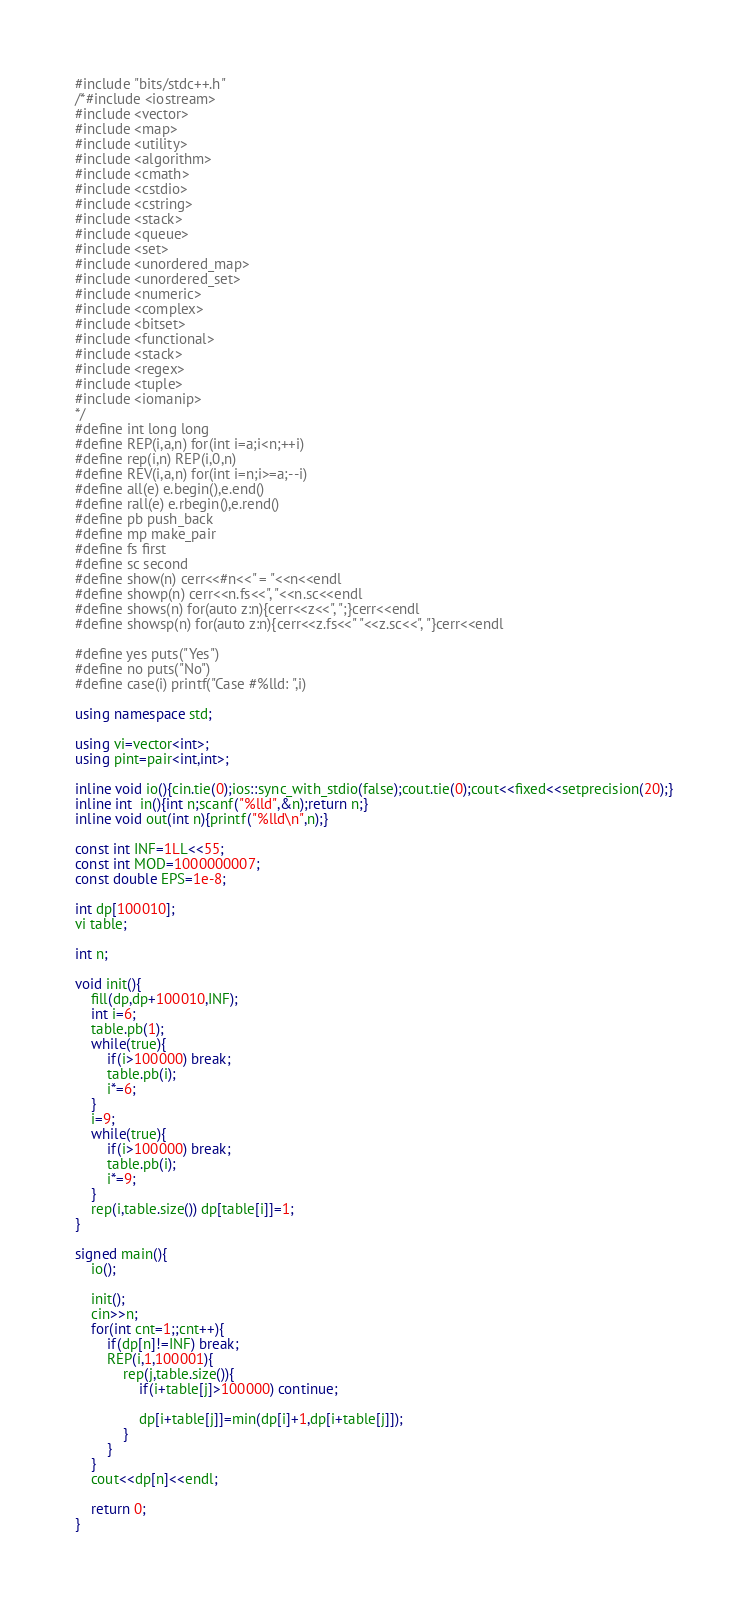<code> <loc_0><loc_0><loc_500><loc_500><_C++_>#include "bits/stdc++.h"
/*#include <iostream>
#include <vector>
#include <map>
#include <utility>
#include <algorithm>
#include <cmath>
#include <cstdio>
#include <cstring>
#include <stack>
#include <queue>
#include <set>
#include <unordered_map>
#include <unordered_set>
#include <numeric>
#include <complex>
#include <bitset>
#include <functional>
#include <stack>
#include <regex>
#include <tuple>
#include <iomanip>
*/
#define int long long
#define REP(i,a,n) for(int i=a;i<n;++i)
#define rep(i,n) REP(i,0,n)
#define REV(i,a,n) for(int i=n;i>=a;--i)
#define all(e) e.begin(),e.end()
#define rall(e) e.rbegin(),e.rend()
#define pb push_back
#define mp make_pair
#define fs first
#define sc second
#define show(n) cerr<<#n<<" = "<<n<<endl
#define showp(n) cerr<<n.fs<<", "<<n.sc<<endl
#define shows(n) for(auto z:n){cerr<<z<<", ";}cerr<<endl
#define showsp(n) for(auto z:n){cerr<<z.fs<<" "<<z.sc<<", "}cerr<<endl

#define yes puts("Yes")
#define no puts("No")
#define case(i) printf("Case #%lld: ",i)

using namespace std;

using vi=vector<int>;
using pint=pair<int,int>;

inline void io(){cin.tie(0);ios::sync_with_stdio(false);cout.tie(0);cout<<fixed<<setprecision(20);}
inline int  in(){int n;scanf("%lld",&n);return n;}
inline void out(int n){printf("%lld\n",n);}

const int INF=1LL<<55;
const int MOD=1000000007;
const double EPS=1e-8;

int dp[100010];
vi table;

int n;

void init(){
    fill(dp,dp+100010,INF);
    int i=6;
    table.pb(1);
    while(true){
        if(i>100000) break;
        table.pb(i);
        i*=6;
    }
    i=9;
    while(true){
        if(i>100000) break;
        table.pb(i);
        i*=9;
    }
    rep(i,table.size()) dp[table[i]]=1;
}

signed main(){
    io();

    init();
    cin>>n;
    for(int cnt=1;;cnt++){
        if(dp[n]!=INF) break;
        REP(i,1,100001){
            rep(j,table.size()){
                if(i+table[j]>100000) continue;
                
                dp[i+table[j]]=min(dp[i]+1,dp[i+table[j]]);
            }
        }
    } 
    cout<<dp[n]<<endl;

    return 0;
}
</code> 